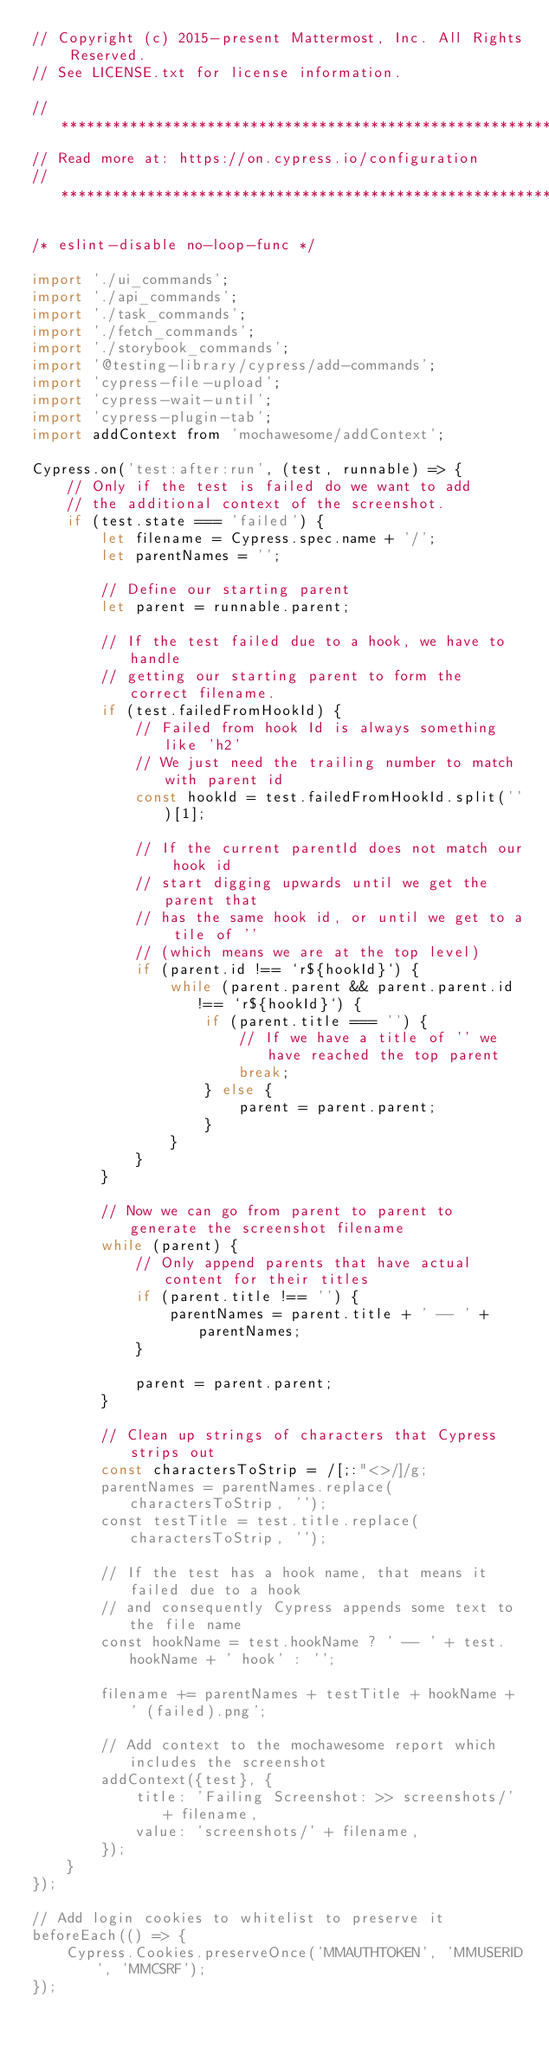<code> <loc_0><loc_0><loc_500><loc_500><_JavaScript_>// Copyright (c) 2015-present Mattermost, Inc. All Rights Reserved.
// See LICENSE.txt for license information.

// ***********************************************************
// Read more at: https://on.cypress.io/configuration
// ***********************************************************

/* eslint-disable no-loop-func */

import './ui_commands';
import './api_commands';
import './task_commands';
import './fetch_commands';
import './storybook_commands';
import '@testing-library/cypress/add-commands';
import 'cypress-file-upload';
import 'cypress-wait-until';
import 'cypress-plugin-tab';
import addContext from 'mochawesome/addContext';

Cypress.on('test:after:run', (test, runnable) => {
    // Only if the test is failed do we want to add
    // the additional context of the screenshot.
    if (test.state === 'failed') {
        let filename = Cypress.spec.name + '/';
        let parentNames = '';

        // Define our starting parent
        let parent = runnable.parent;

        // If the test failed due to a hook, we have to handle
        // getting our starting parent to form the correct filename.
        if (test.failedFromHookId) {
            // Failed from hook Id is always something like 'h2'
            // We just need the trailing number to match with parent id
            const hookId = test.failedFromHookId.split('')[1];

            // If the current parentId does not match our hook id
            // start digging upwards until we get the parent that
            // has the same hook id, or until we get to a tile of ''
            // (which means we are at the top level)
            if (parent.id !== `r${hookId}`) {
                while (parent.parent && parent.parent.id !== `r${hookId}`) {
                    if (parent.title === '') {
                        // If we have a title of '' we have reached the top parent
                        break;
                    } else {
                        parent = parent.parent;
                    }
                }
            }
        }

        // Now we can go from parent to parent to generate the screenshot filename
        while (parent) {
            // Only append parents that have actual content for their titles
            if (parent.title !== '') {
                parentNames = parent.title + ' -- ' + parentNames;
            }

            parent = parent.parent;
        }

        // Clean up strings of characters that Cypress strips out
        const charactersToStrip = /[;:"<>/]/g;
        parentNames = parentNames.replace(charactersToStrip, '');
        const testTitle = test.title.replace(charactersToStrip, '');

        // If the test has a hook name, that means it failed due to a hook
        // and consequently Cypress appends some text to the file name
        const hookName = test.hookName ? ' -- ' + test.hookName + ' hook' : '';

        filename += parentNames + testTitle + hookName + ' (failed).png';

        // Add context to the mochawesome report which includes the screenshot
        addContext({test}, {
            title: 'Failing Screenshot: >> screenshots/' + filename,
            value: 'screenshots/' + filename,
        });
    }
});

// Add login cookies to whitelist to preserve it
beforeEach(() => {
    Cypress.Cookies.preserveOnce('MMAUTHTOKEN', 'MMUSERID', 'MMCSRF');
});
</code> 